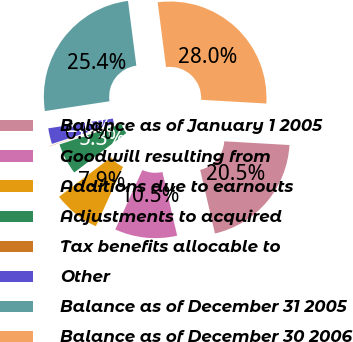Convert chart. <chart><loc_0><loc_0><loc_500><loc_500><pie_chart><fcel>Balance as of January 1 2005<fcel>Goodwill resulting from<fcel>Additions due to earnouts<fcel>Adjustments to acquired<fcel>Tax benefits allocable to<fcel>Other<fcel>Balance as of December 31 2005<fcel>Balance as of December 30 2006<nl><fcel>20.46%<fcel>10.45%<fcel>7.85%<fcel>5.25%<fcel>0.04%<fcel>2.64%<fcel>25.35%<fcel>27.95%<nl></chart> 